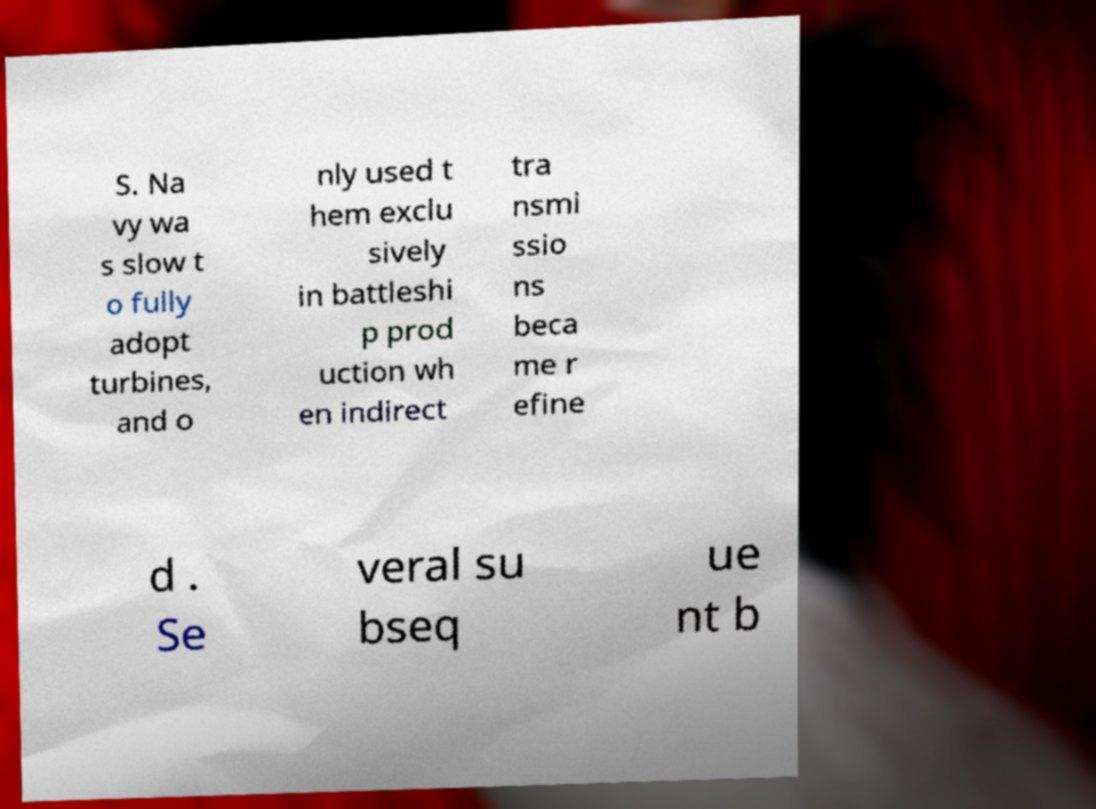Please identify and transcribe the text found in this image. S. Na vy wa s slow t o fully adopt turbines, and o nly used t hem exclu sively in battleshi p prod uction wh en indirect tra nsmi ssio ns beca me r efine d . Se veral su bseq ue nt b 